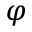Convert formula to latex. <formula><loc_0><loc_0><loc_500><loc_500>\varphi</formula> 